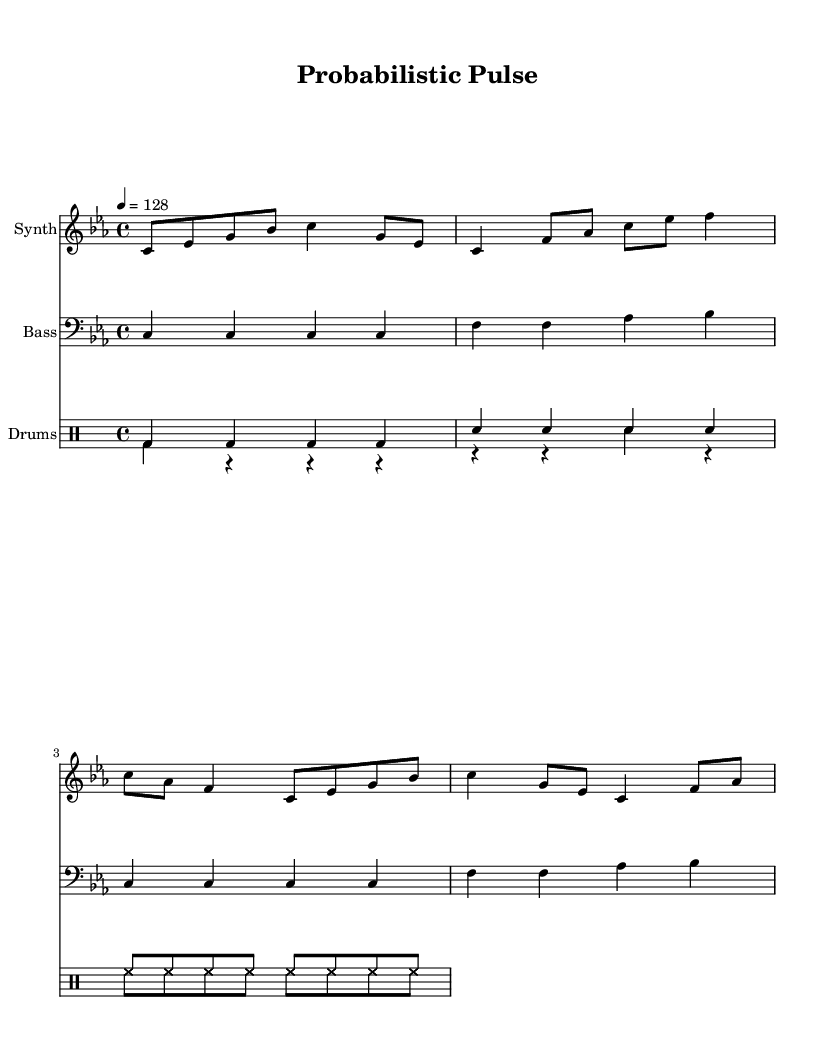What is the key signature of this music? The key signature is C minor, which has three flats (B, E, A). This is evident from the key signature indicated at the beginning of the score.
Answer: C minor What is the time signature of this piece? The time signature is 4/4, meaning there are four beats per measure and a quarter note gets one beat. This is shown at the beginning of the score.
Answer: 4/4 What is the tempo marking for this music? The tempo marking indicates a speed of 128 beats per minute. This is indicated by the specification '4 = 128' at the beginning of the score.
Answer: 128 How many measures are in the synth part? The synth part contains four measures, which can be counted by looking at the bars in the staff. There are four sets of vertical lines separating the music into sections.
Answer: 4 How does the volume of the bass compare to the synth? The bass typically plays at a lower octave than the synth, creating a contrast in texture and depth, which is a common characteristic in house music. This can be observed by comparing the range of notes played in each staff.
Answer: Lower What is the primary rhythm pattern of the drums? The primary rhythm pattern in the drum part features a kick drum on each beat and hi-hats playing eighth notes, creating a steady groove typical in house music. This can be deduced by analyzing the drum notation across the measures.
Answer: Kick and hi-hat What forms of percussion are used in this piece? The percussion includes bass drum, snare drum, and hi-hat. This is determined by the notation used in the drum staff, which indicates different percussion instruments.
Answer: Bass drum, snare drum, hi-hat 